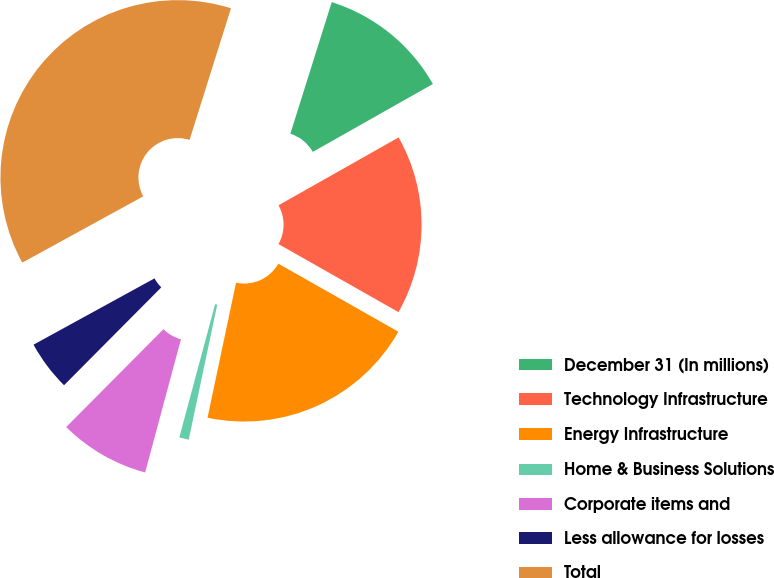Convert chart. <chart><loc_0><loc_0><loc_500><loc_500><pie_chart><fcel>December 31 (In millions)<fcel>Technology Infrastructure<fcel>Energy Infrastructure<fcel>Home & Business Solutions<fcel>Corporate items and<fcel>Less allowance for losses<fcel>Total<nl><fcel>11.96%<fcel>16.4%<fcel>20.1%<fcel>0.87%<fcel>8.27%<fcel>4.57%<fcel>37.83%<nl></chart> 